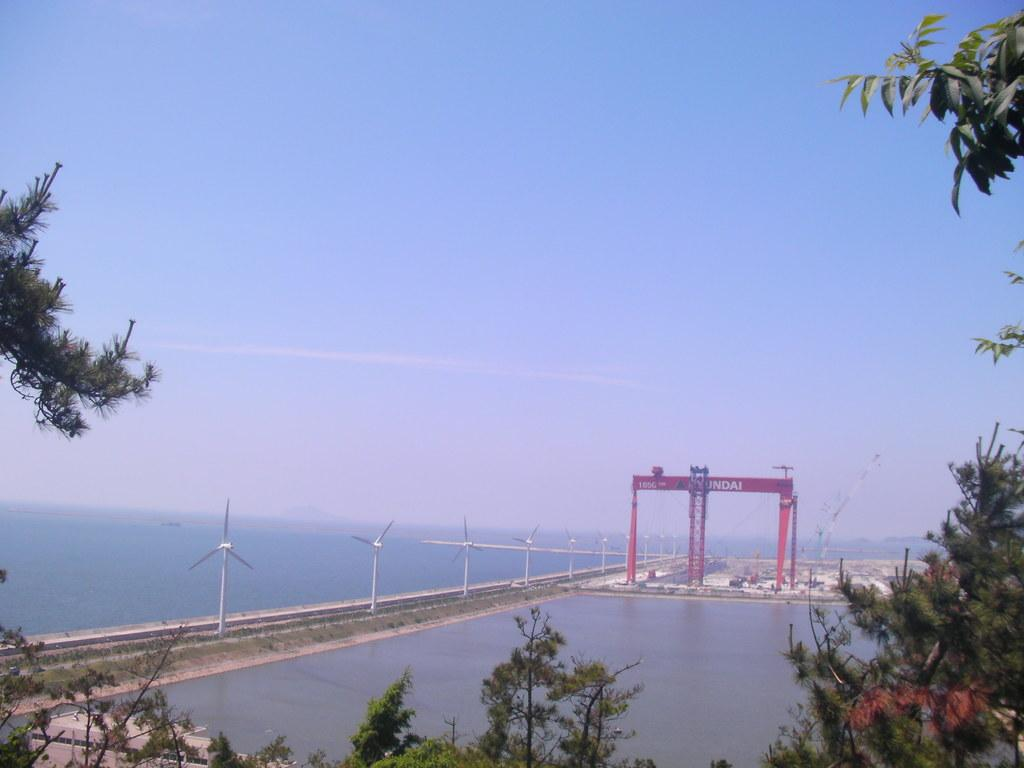What type of vegetation can be seen in the image? There are branches of trees in the image. What natural element is present in the image? There is water visible in the image. What type of equipment is in the image? There are wind fans in the image. What architectural feature can be seen in the background? There is an arch with some text in the background. What is visible in the sky in the image? The sky is visible in the background. Can you tell me what type of doctor is standing near the arch in the image? There is no doctor present in the image; it features branches of trees, water, wind fans, an arch with text, and a visible sky. Is there a cave visible in the image? There is no cave present in the image. 